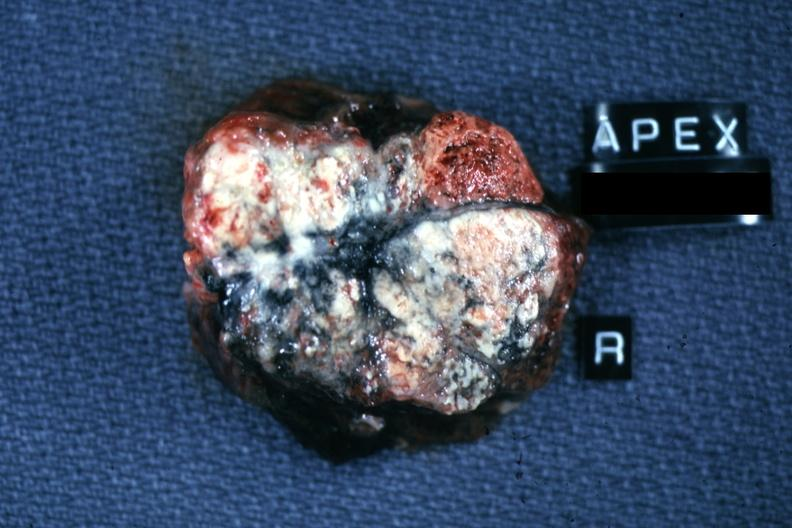what is present?
Answer the question using a single word or phrase. Metastatic carcinoma 